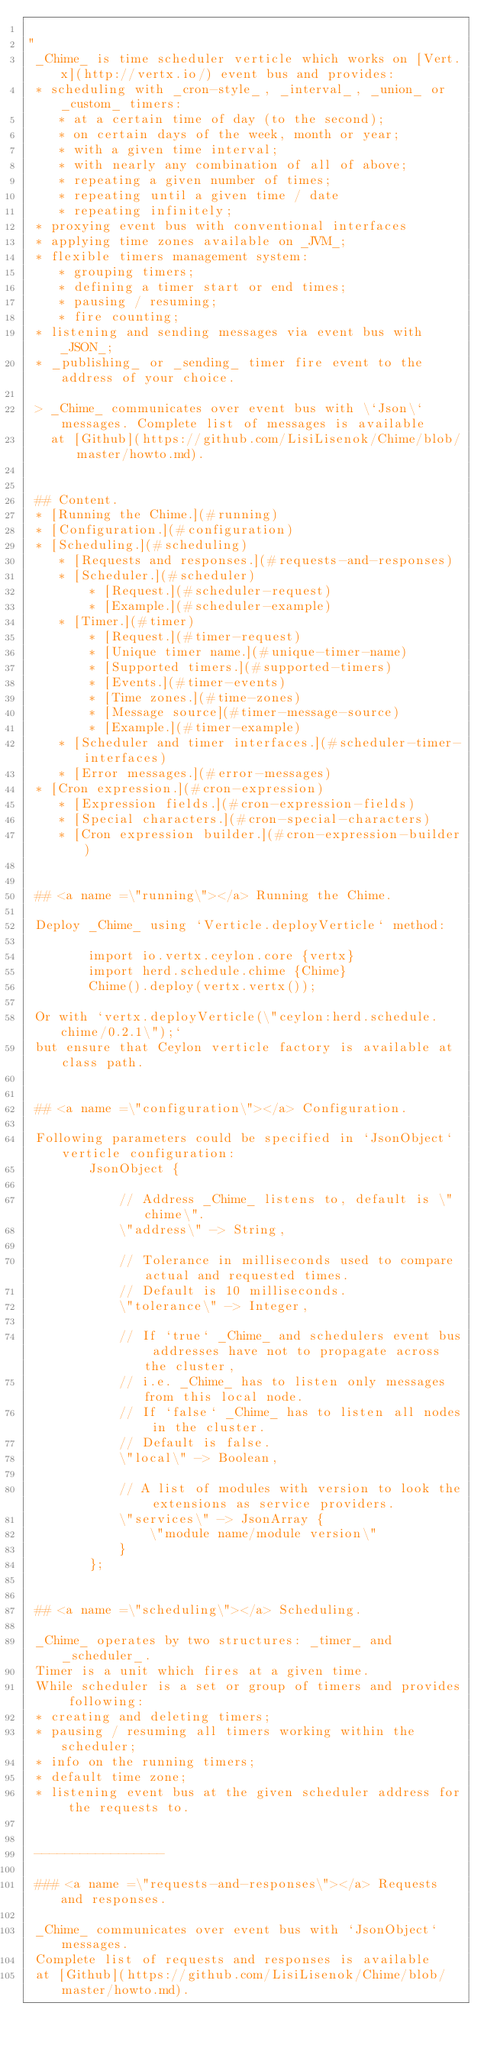<code> <loc_0><loc_0><loc_500><loc_500><_Ceylon_>
"
 _Chime_ is time scheduler verticle which works on [Vert.x](http://vertx.io/) event bus and provides:  
 * scheduling with _cron-style_, _interval_, _union_ or _custom_ timers:
 	* at a certain time of day (to the second);  
 	* on certain days of the week, month or year;  
 	* with a given time interval;  
 	* with nearly any combination of all of above;  
 	* repeating a given number of times;  
 	* repeating until a given time / date  
 	* repeating infinitely;  
 * proxying event bus with conventional interfaces  
 * applying time zones available on _JVM_;  
 * flexible timers management system:  
 	* grouping timers;  
 	* defining a timer start or end times;  
 	* pausing / resuming;  
 	* fire counting;  
 * listening and sending messages via event bus with _JSON_;  
 * _publishing_ or _sending_ timer fire event to the address of your choice.  
 
 > _Chime_ communicates over event bus with \`Json\` messages. Complete list of messages is available
   at [Github](https://github.com/LisiLisenok/Chime/blob/master/howto.md).  
 
 
 ## Content.  
 * [Running the Chime.](#running)  
 * [Configuration.](#configuration)  
 * [Scheduling.](#scheduling)  
 	* [Requests and responses.](#requests-and-responses)  
 	* [Scheduler.](#scheduler)  
 		* [Request.](#scheduler-request)  
 		* [Example.](#scheduler-example)  
 	* [Timer.](#timer)  
 		* [Request.](#timer-request)  
 		* [Unique timer name.](#unique-timer-name)  
 		* [Supported timers.](#supported-timers)  
 		* [Events.](#timer-events)  
 		* [Time zones.](#time-zones)  
 		* [Message source](#timer-message-source)
 		* [Example.](#timer-example)  
 	* [Scheduler and timer interfaces.](#scheduler-timer-interfaces)  
 	* [Error messages.](#error-messages)  
 * [Cron expression.](#cron-expression)  
 	* [Expression fields.](#cron-expression-fields)  
 	* [Special characters.](#cron-special-characters)  
 	* [Cron expression builder.](#cron-expression-builder)  
 
 
 ## <a name =\"running\"></a> Running the Chime.
 
 Deploy _Chime_ using `Verticle.deployVerticle` method:  
 
 		import io.vertx.ceylon.core {vertx}
 		import herd.schedule.chime {Chime}
 		Chime().deploy(vertx.vertx());
 
 Or with `vertx.deployVerticle(\"ceylon:herd.schedule.chime/0.2.1\");`
 but ensure that Ceylon verticle factory is available at class path.  
 
 
 ## <a name =\"configuration\"></a> Configuration.
 
 Following parameters could be specified in `JsonObject` verticle configuration:  
 		JsonObject {
 			
 			// Address _Chime_ listens to, default is \"chime\".
 			\"address\" -> String,
 			
 			// Tolerance in milliseconds used to compare actual and requested times.
 			// Default is 10 milliseconds.
 			\"tolerance\" -> Integer,
 			
 			// If `true` _Chime_ and schedulers event bus addresses have not to propagate across the cluster,
 			// i.e. _Chime_ has to listen only messages from this local node.
 			// If `false` _Chime_ has to listen all nodes in the cluster.
 			// Default is false.
 			\"local\" -> Boolean,
 			
 			// A list of modules with version to look the extensions as service providers. 
 			\"services\" -> JsonArray {
 				\"module name/module version\"
 			}
 		};
 
 
 ## <a name =\"scheduling\"></a> Scheduling.  
 
 _Chime_ operates by two structures: _timer_ and _scheduler_.  
 Timer is a unit which fires at a given time.
 While scheduler is a set or group of timers and provides following:    
 * creating and deleting timers;  
 * pausing / resuming all timers working within the scheduler;  
 * info on the running timers;  
 * default time zone;  
 * listening event bus at the given scheduler address for the requests to.  
 
  
 -----------------
 
 ### <a name =\"requests-and-responses\"></a> Requests and responses.  
 
 _Chime_ communicates over event bus with `JsonObject` messages.
 Complete list of requests and responses is available
 at [Github](https://github.com/LisiLisenok/Chime/blob/master/howto.md).  
 </code> 